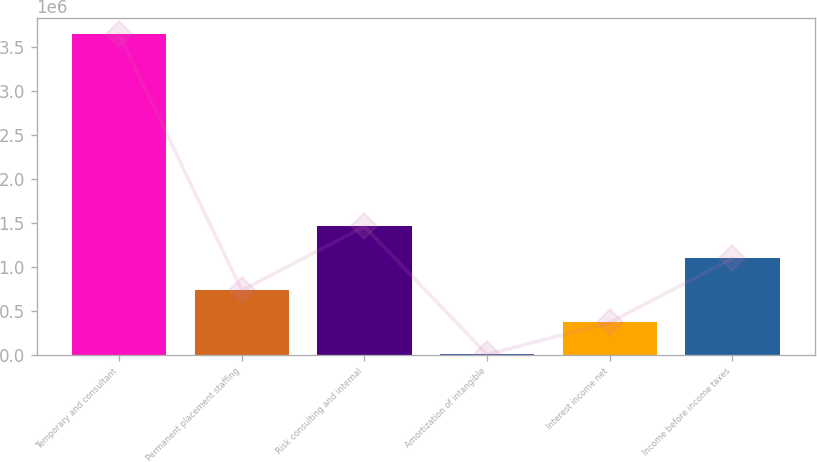Convert chart to OTSL. <chart><loc_0><loc_0><loc_500><loc_500><bar_chart><fcel>Temporary and consultant<fcel>Permanent placement staffing<fcel>Risk consulting and internal<fcel>Amortization of intangible<fcel>Interest income net<fcel>Income before income taxes<nl><fcel>3.64927e+06<fcel>731930<fcel>1.46127e+06<fcel>2594<fcel>367262<fcel>1.0966e+06<nl></chart> 